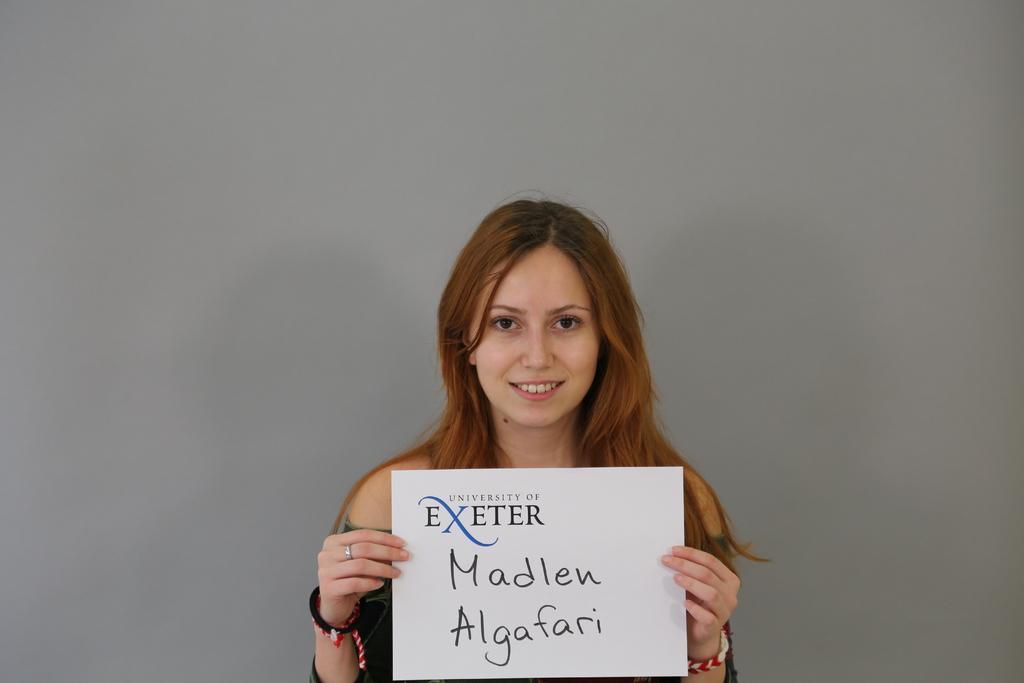Please provide a concise description of this image. In this picture there is a woman smiling and she is holding the board and there is text on the board. At the back it looks like a wall. 